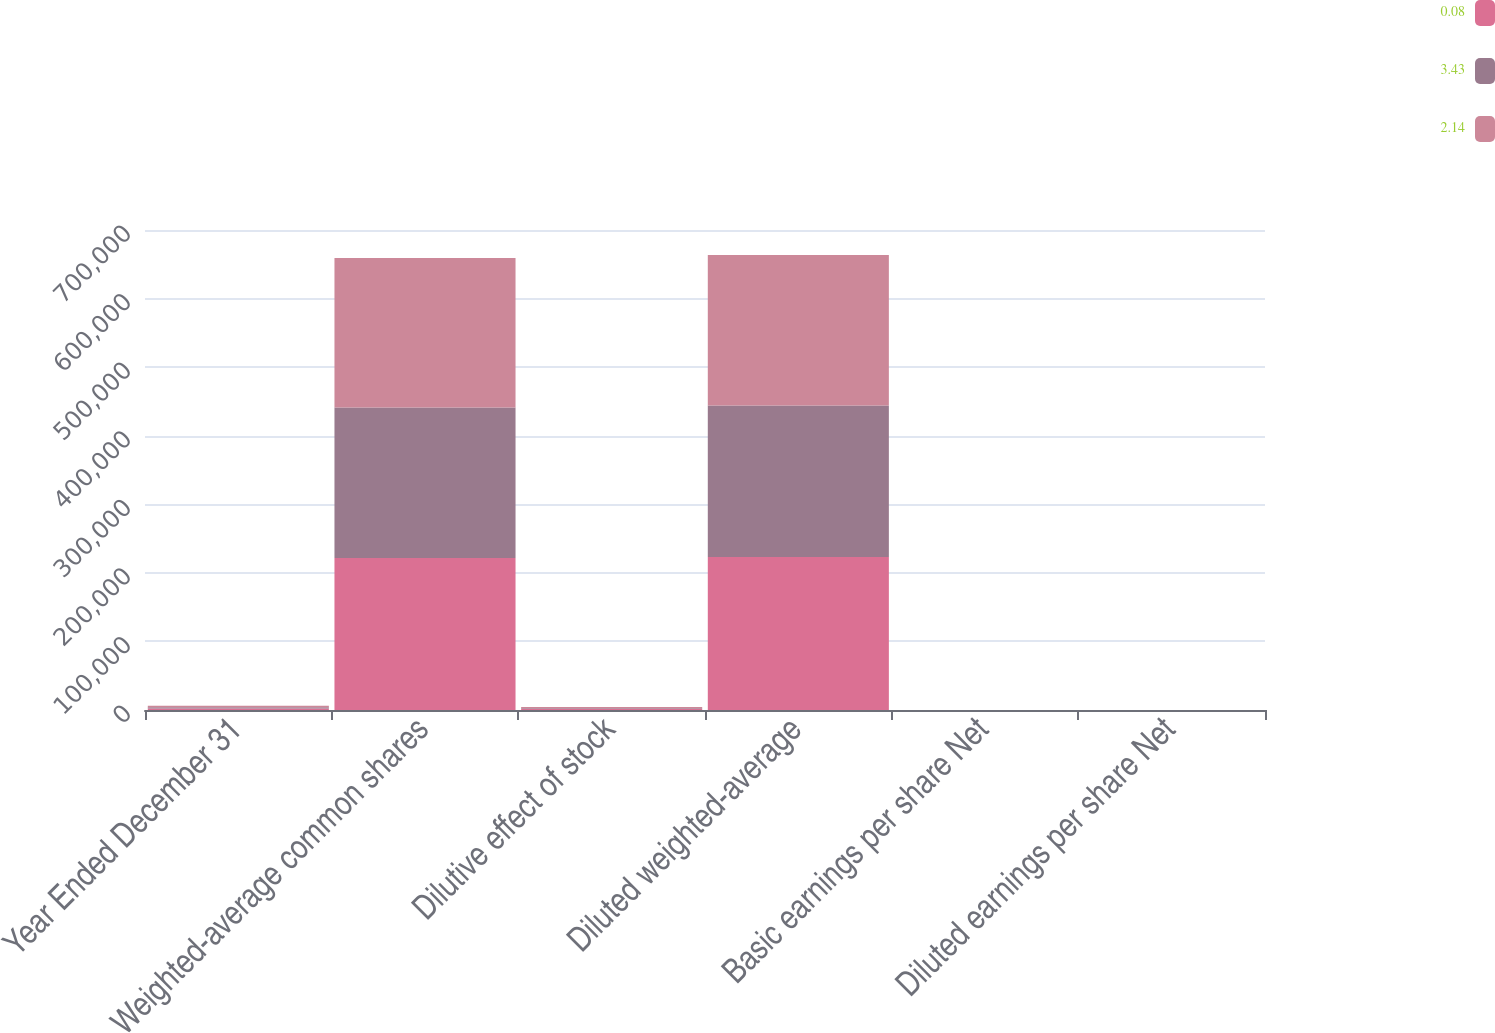<chart> <loc_0><loc_0><loc_500><loc_500><stacked_bar_chart><ecel><fcel>Year Ended December 31<fcel>Weighted-average common shares<fcel>Dilutive effect of stock<fcel>Diluted weighted-average<fcel>Basic earnings per share Net<fcel>Diluted earnings per share Net<nl><fcel>0.08<fcel>2014<fcel>221658<fcel>1386<fcel>223044<fcel>3.45<fcel>3.43<nl><fcel>3.43<fcel>2013<fcel>219638<fcel>1303<fcel>220941<fcel>2.16<fcel>2.14<nl><fcel>2.14<fcel>2012<fcel>217930<fcel>1527<fcel>219457<fcel>0.08<fcel>0.08<nl></chart> 